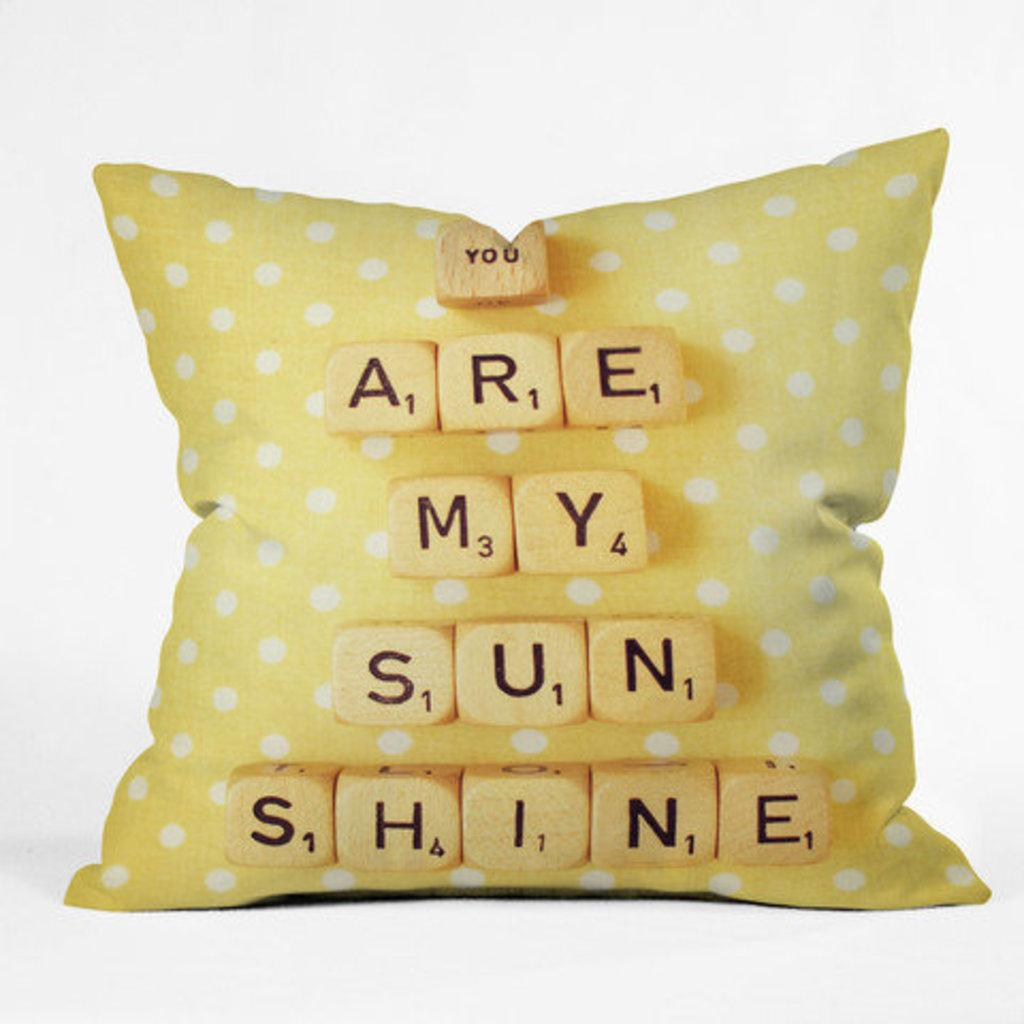What object is present in the image that people might sit on? There is a cushion in the image that people might sit on. What can be found on the surface of the cushion? The cushion has text on it. What color is the background of the image? The background of the image is white. How many sticks are visible in the image? There are no sticks present in the image. 